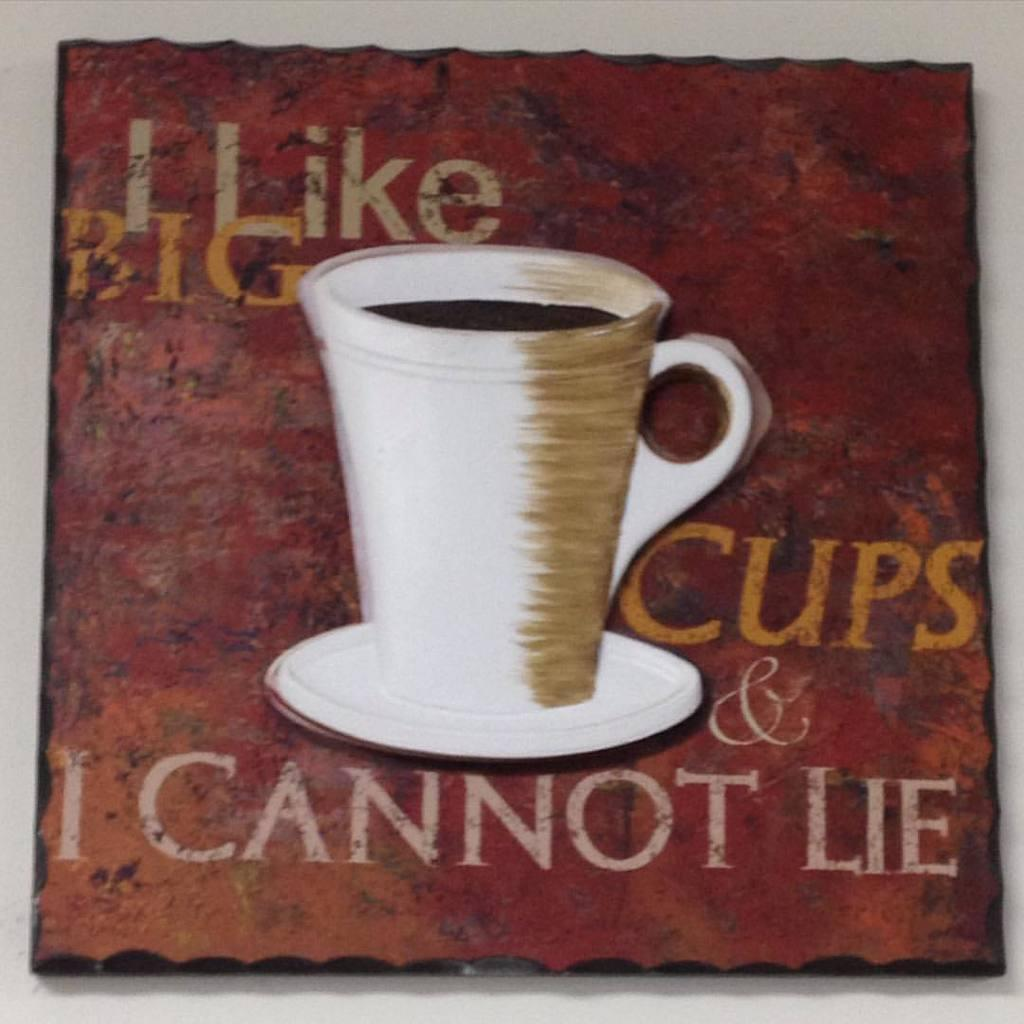<image>
Render a clear and concise summary of the photo. A painting of a cup of coffee with a slogan about big cups. 